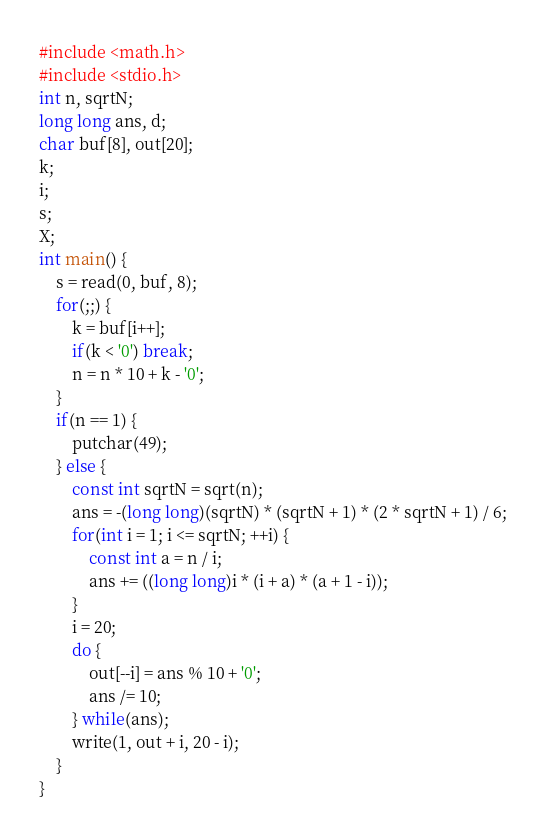<code> <loc_0><loc_0><loc_500><loc_500><_C_>#include <math.h>
#include <stdio.h>
int n, sqrtN;
long long ans, d;
char buf[8], out[20];
k;
i;
s;
X;
int main() {
    s = read(0, buf, 8);
    for(;;) {
        k = buf[i++];
        if(k < '0') break;
        n = n * 10 + k - '0';
    }
    if(n == 1) {
        putchar(49);
    } else {
        const int sqrtN = sqrt(n);
        ans = -(long long)(sqrtN) * (sqrtN + 1) * (2 * sqrtN + 1) / 6;
        for(int i = 1; i <= sqrtN; ++i) {
            const int a = n / i;
            ans += ((long long)i * (i + a) * (a + 1 - i));
        }
        i = 20;
        do {
            out[--i] = ans % 10 + '0';
            ans /= 10;
        } while(ans);
        write(1, out + i, 20 - i);
    }
}
</code> 